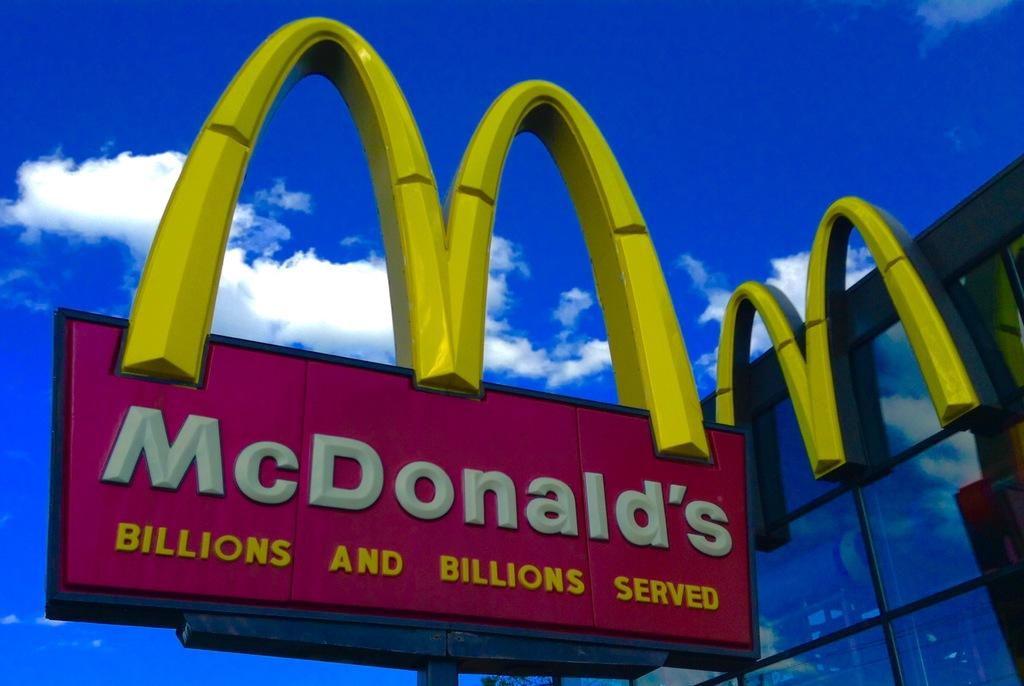<image>
Present a compact description of the photo's key features. A McDonald's sign out next to a building with lots of glass windows. 